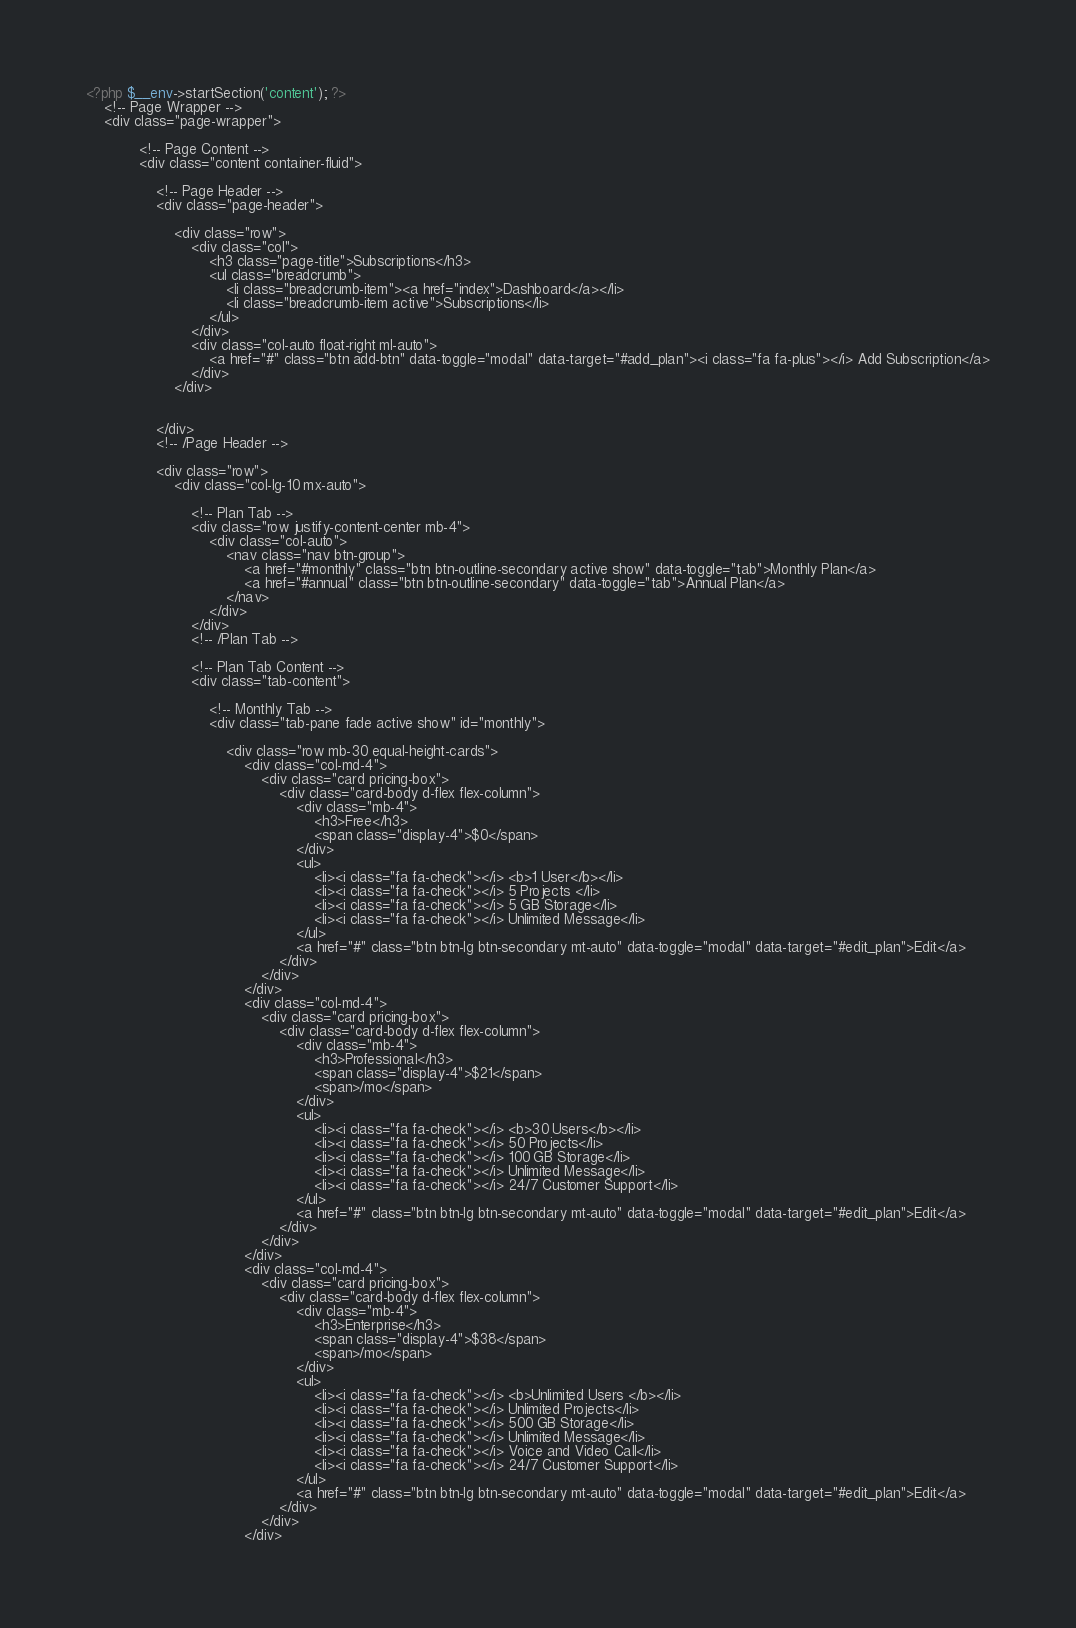<code> <loc_0><loc_0><loc_500><loc_500><_PHP_>
<?php $__env->startSection('content'); ?>
	<!-- Page Wrapper -->
    <div class="page-wrapper">
			
            <!-- Page Content -->
            <div class="content container-fluid">
                
                <!-- Page Header -->
                <div class="page-header">
                    
                    <div class="row">
                        <div class="col">
                            <h3 class="page-title">Subscriptions</h3>
                            <ul class="breadcrumb">
                                <li class="breadcrumb-item"><a href="index">Dashboard</a></li>
                                <li class="breadcrumb-item active">Subscriptions</li>
                            </ul>
                        </div>
                        <div class="col-auto float-right ml-auto">
                            <a href="#" class="btn add-btn" data-toggle="modal" data-target="#add_plan"><i class="fa fa-plus"></i> Add Subscription</a>
                        </div>
                    </div>
      
            
                </div>
                <!-- /Page Header -->
            
                <div class="row">
                    <div class="col-lg-10 mx-auto">
                    
                        <!-- Plan Tab -->
                        <div class="row justify-content-center mb-4">
                            <div class="col-auto">
                                <nav class="nav btn-group">
                                    <a href="#monthly" class="btn btn-outline-secondary active show" data-toggle="tab">Monthly Plan</a>
                                    <a href="#annual" class="btn btn-outline-secondary" data-toggle="tab">Annual Plan</a>
                                </nav>
                            </div>
                        </div>
                        <!-- /Plan Tab -->

                        <!-- Plan Tab Content -->
                        <div class="tab-content">
                        
                            <!-- Monthly Tab -->
                            <div class="tab-pane fade active show" id="monthly">
                            
                                <div class="row mb-30 equal-height-cards">
                                    <div class="col-md-4">
                                        <div class="card pricing-box">
                                            <div class="card-body d-flex flex-column">
                                                <div class="mb-4">
                                                    <h3>Free</h3>
                                                    <span class="display-4">$0</span>
                                                </div>
                                                <ul>
                                                    <li><i class="fa fa-check"></i> <b>1 User</b></li>
                                                    <li><i class="fa fa-check"></i> 5 Projects </li>
                                                    <li><i class="fa fa-check"></i> 5 GB Storage</li>
                                                    <li><i class="fa fa-check"></i> Unlimited Message</li>
                                                </ul>
                                                <a href="#" class="btn btn-lg btn-secondary mt-auto" data-toggle="modal" data-target="#edit_plan">Edit</a>
                                            </div>
                                        </div>
                                    </div>
                                    <div class="col-md-4">
                                        <div class="card pricing-box">
                                            <div class="card-body d-flex flex-column">
                                                <div class="mb-4">
                                                    <h3>Professional</h3>
                                                    <span class="display-4">$21</span>
                                                    <span>/mo</span>
                                                </div>
                                                <ul>
                                                    <li><i class="fa fa-check"></i> <b>30 Users</b></li>
                                                    <li><i class="fa fa-check"></i> 50 Projects</li>
                                                    <li><i class="fa fa-check"></i> 100 GB Storage</li>
                                                    <li><i class="fa fa-check"></i> Unlimited Message</li>
                                                    <li><i class="fa fa-check"></i> 24/7 Customer Support</li>
                                                </ul>
                                                <a href="#" class="btn btn-lg btn-secondary mt-auto" data-toggle="modal" data-target="#edit_plan">Edit</a>
                                            </div>
                                        </div>
                                    </div>
                                    <div class="col-md-4">
                                        <div class="card pricing-box">
                                            <div class="card-body d-flex flex-column">
                                                <div class="mb-4">
                                                    <h3>Enterprise</h3>
                                                    <span class="display-4">$38</span>
                                                    <span>/mo</span>
                                                </div>
                                                <ul>
                                                    <li><i class="fa fa-check"></i> <b>Unlimited Users </b></li>
                                                    <li><i class="fa fa-check"></i> Unlimited Projects</li>
                                                    <li><i class="fa fa-check"></i> 500 GB Storage</li>
                                                    <li><i class="fa fa-check"></i> Unlimited Message</li>
                                                    <li><i class="fa fa-check"></i> Voice and Video Call</li>
                                                    <li><i class="fa fa-check"></i> 24/7 Customer Support</li>
                                                </ul>
                                                <a href="#" class="btn btn-lg btn-secondary mt-auto" data-toggle="modal" data-target="#edit_plan">Edit</a>
                                            </div>
                                        </div>
                                    </div></code> 